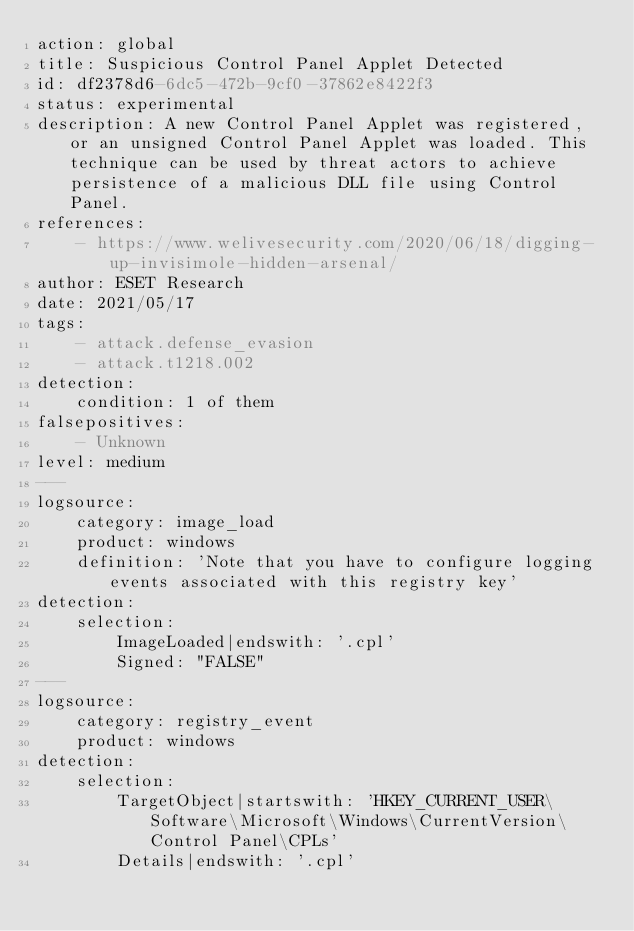Convert code to text. <code><loc_0><loc_0><loc_500><loc_500><_YAML_>action: global
title: Suspicious Control Panel Applet Detected
id: df2378d6-6dc5-472b-9cf0-37862e8422f3
status: experimental
description: A new Control Panel Applet was registered, or an unsigned Control Panel Applet was loaded. This technique can be used by threat actors to achieve persistence of a malicious DLL file using Control Panel.
references:
    - https://www.welivesecurity.com/2020/06/18/digging-up-invisimole-hidden-arsenal/
author: ESET Research
date: 2021/05/17
tags:
    - attack.defense_evasion
    - attack.t1218.002
detection:
    condition: 1 of them
falsepositives:
    - Unknown
level: medium
---
logsource:
    category: image_load
    product: windows
    definition: 'Note that you have to configure logging events associated with this registry key'
detection:
    selection:
        ImageLoaded|endswith: '.cpl'
        Signed: "FALSE"
---
logsource:
    category: registry_event
    product: windows
detection:
    selection:
        TargetObject|startswith: 'HKEY_CURRENT_USER\Software\Microsoft\Windows\CurrentVersion\Control Panel\CPLs'
        Details|endswith: '.cpl'</code> 